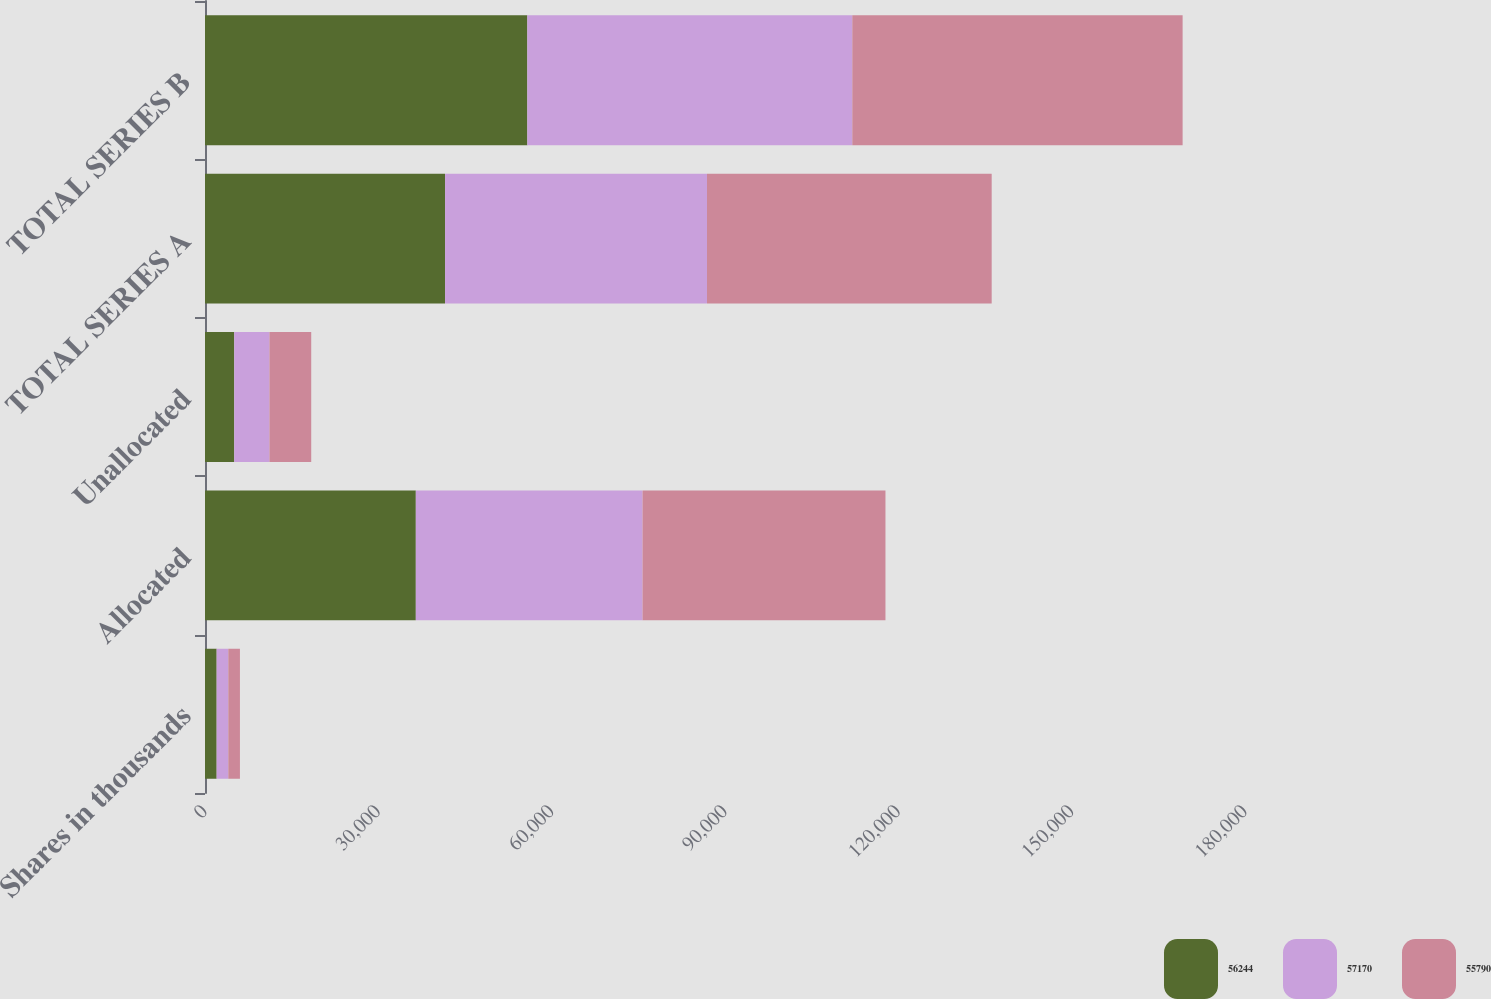<chart> <loc_0><loc_0><loc_500><loc_500><stacked_bar_chart><ecel><fcel>Shares in thousands<fcel>Allocated<fcel>Unallocated<fcel>TOTAL SERIES A<fcel>TOTAL SERIES B<nl><fcel>56244<fcel>2017<fcel>36488<fcel>5060<fcel>41548<fcel>55790<nl><fcel>57170<fcel>2016<fcel>39241<fcel>6095<fcel>45336<fcel>56244<nl><fcel>55790<fcel>2015<fcel>42044<fcel>7228<fcel>49272<fcel>57170<nl></chart> 